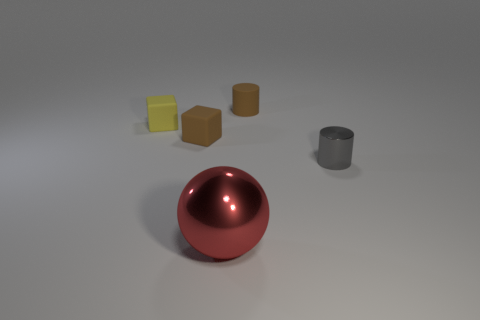Is there any other thing that has the same size as the red sphere?
Offer a very short reply. No. What number of objects are either big metallic balls or things to the right of the big red ball?
Your response must be concise. 3. How many other things are there of the same shape as the small metal object?
Provide a succinct answer. 1. Is the number of small metal cylinders that are to the left of the brown matte cylinder less than the number of big objects in front of the gray thing?
Your response must be concise. Yes. What is the shape of the small thing that is the same material as the large red ball?
Give a very brief answer. Cylinder. Is there any other thing that is the same color as the tiny metal thing?
Make the answer very short. No. The metal thing on the right side of the tiny brown rubber object to the right of the large red metal thing is what color?
Provide a succinct answer. Gray. The object in front of the tiny cylinder right of the cylinder that is behind the gray shiny thing is made of what material?
Offer a terse response. Metal. How many yellow cubes are the same size as the gray shiny thing?
Your response must be concise. 1. What is the thing that is both in front of the yellow thing and behind the gray shiny cylinder made of?
Provide a short and direct response. Rubber. 